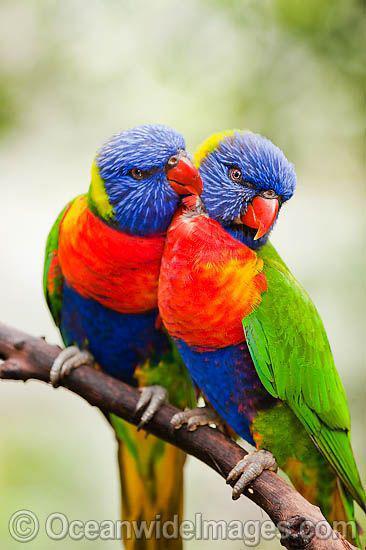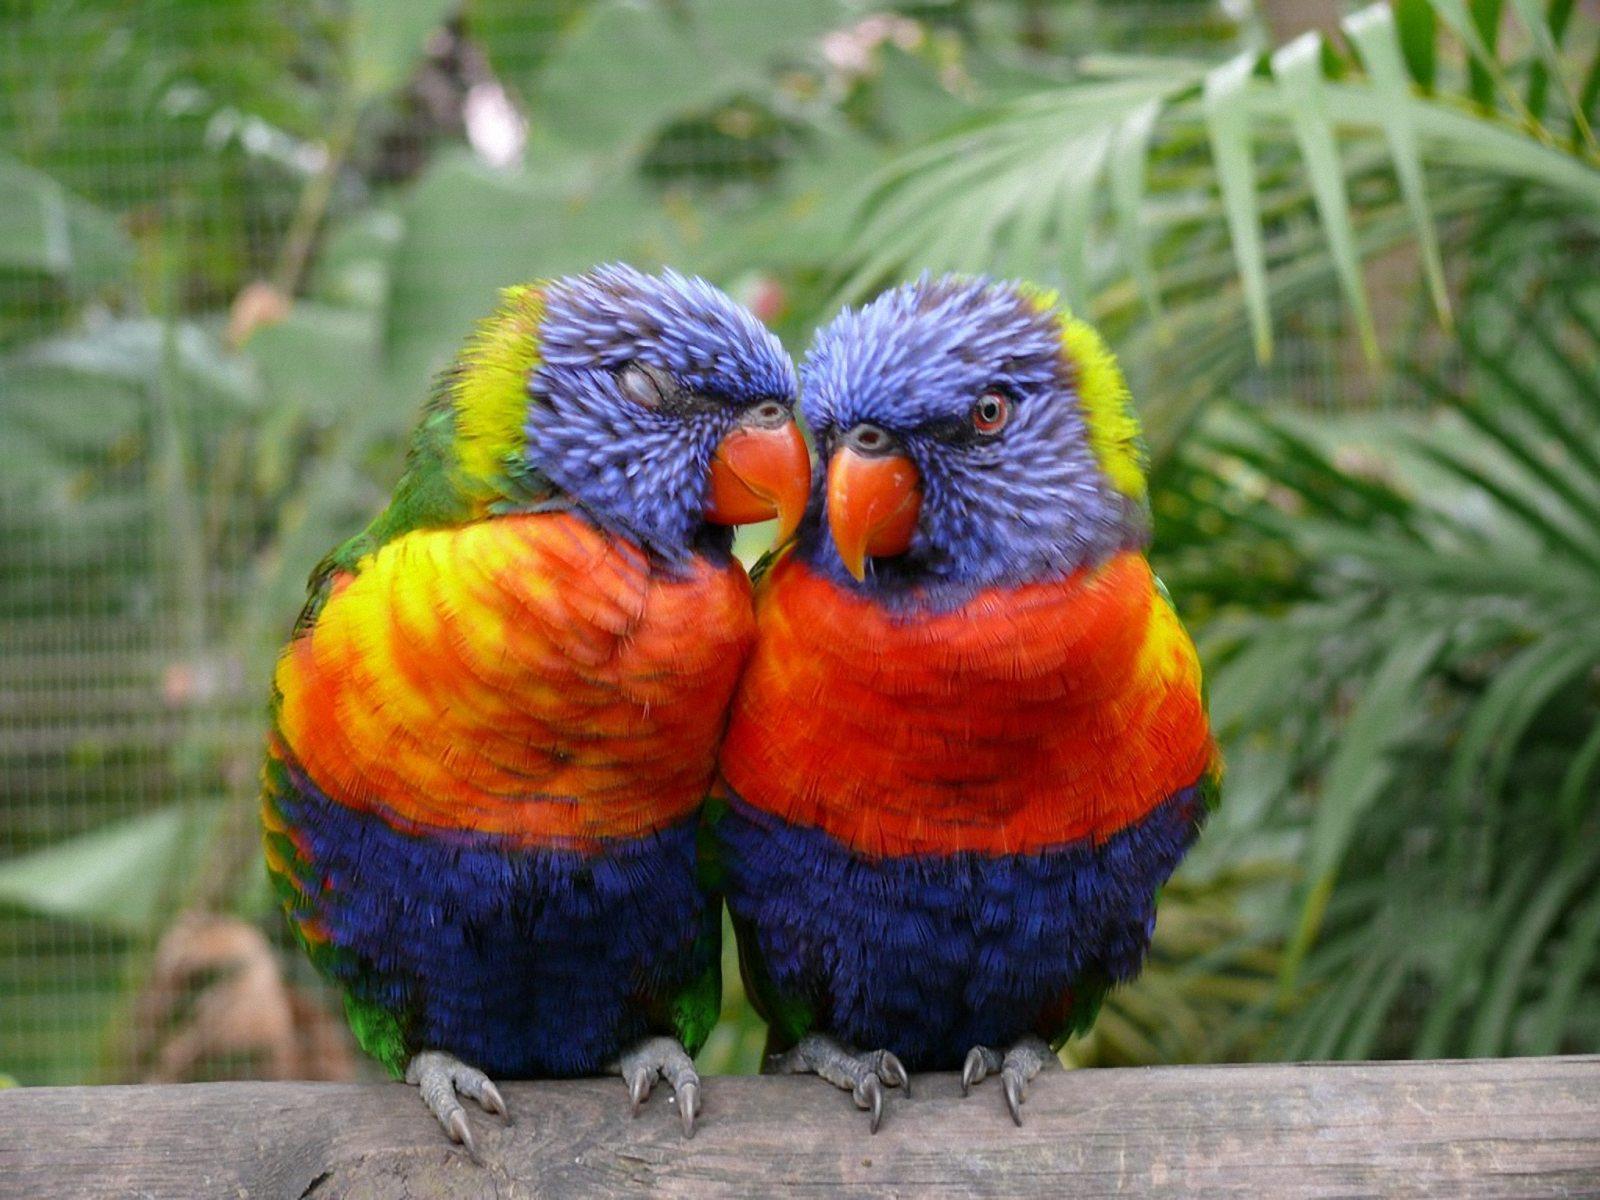The first image is the image on the left, the second image is the image on the right. For the images shown, is this caption "Each image depicts exactly two multi-colored parrots." true? Answer yes or no. Yes. The first image is the image on the left, the second image is the image on the right. Considering the images on both sides, is "Two colorful birds are perched on a wooden fence." valid? Answer yes or no. No. 